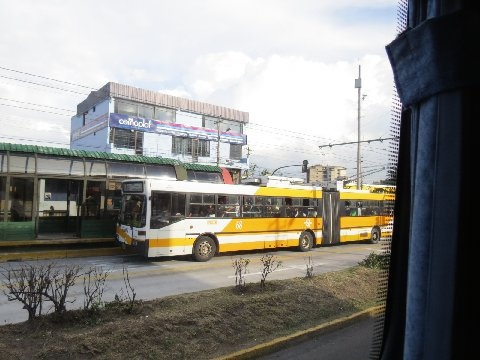Describe the objects in this image and their specific colors. I can see bus in white, gray, ivory, black, and orange tones in this image. 